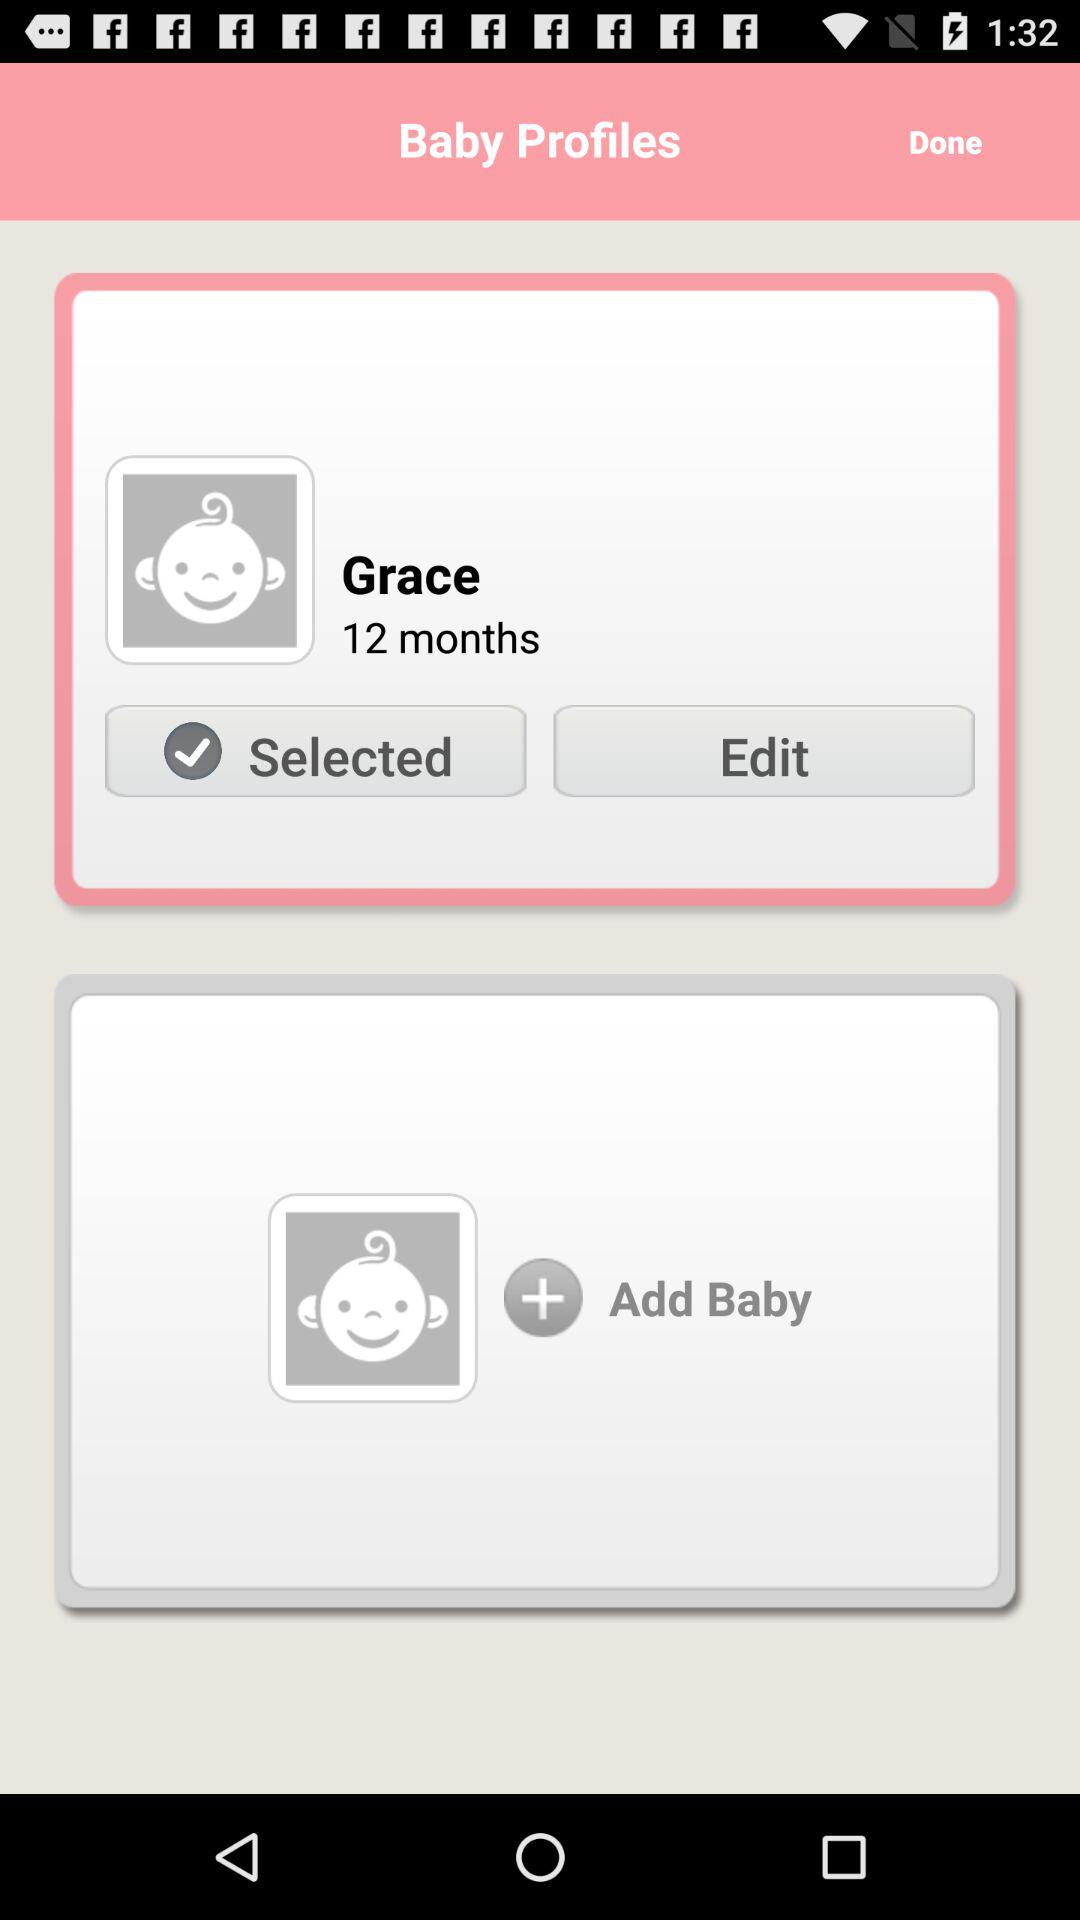How much does Grace weigh?
When the provided information is insufficient, respond with <no answer>. <no answer> 